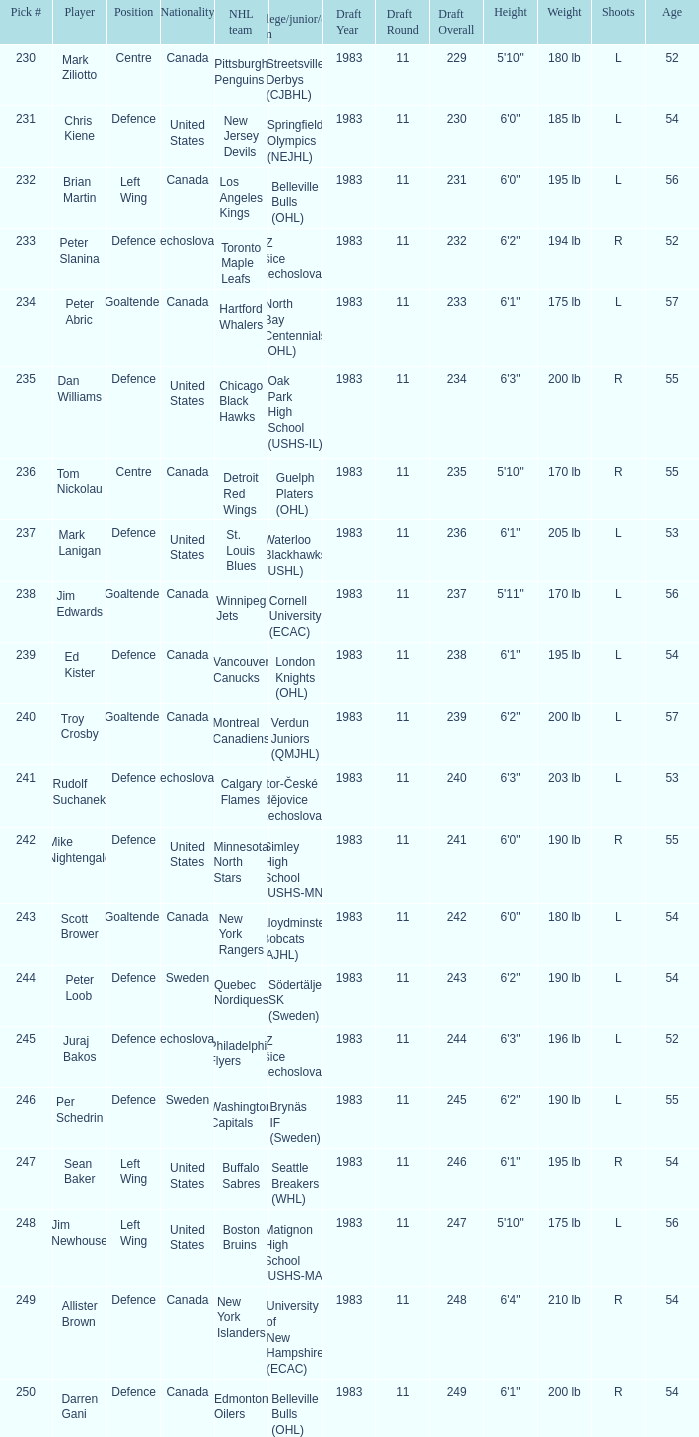What number was the new jersey devils' draft selection? 231.0. 